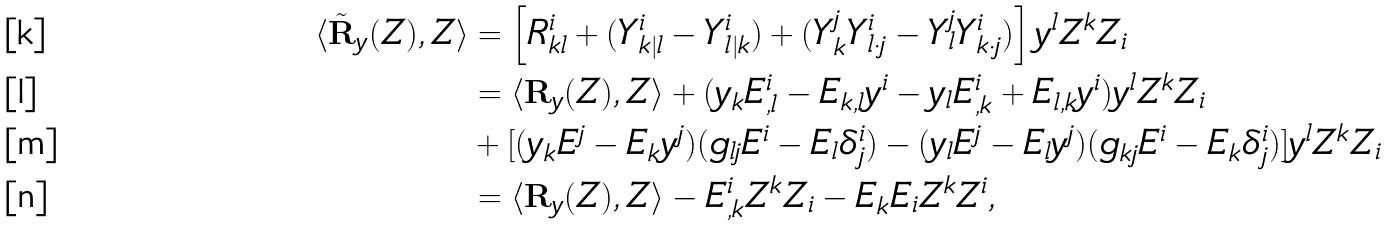Convert formula to latex. <formula><loc_0><loc_0><loc_500><loc_500>\langle \tilde { \mathbf R } _ { y } ( Z ) , Z \rangle & = \left [ R ^ { i } _ { k l } + ( Y ^ { i } _ { k | l } - Y ^ { i } _ { l | k } ) + ( Y ^ { j } _ { k } Y ^ { i } _ { l \cdot j } - Y ^ { j } _ { l } Y ^ { i } _ { k \cdot j } ) \right ] y ^ { l } Z ^ { k } Z _ { i } \\ & = \langle \mathbf R _ { y } ( Z ) , Z \rangle + ( y _ { k } E ^ { i } _ { , l } - E _ { k , l } y ^ { i } - y _ { l } E ^ { i } _ { , k } + E _ { l , k } y ^ { i } ) y ^ { l } Z ^ { k } Z _ { i } \\ & + [ ( y _ { k } E ^ { j } - E _ { k } y ^ { j } ) ( g _ { l j } E ^ { i } - E _ { l } \delta ^ { i } _ { j } ) - ( y _ { l } E ^ { j } - E _ { l } y ^ { j } ) ( g _ { k j } E ^ { i } - E _ { k } \delta ^ { i } _ { j } ) ] y ^ { l } Z ^ { k } Z _ { i } \\ & = \langle \mathbf R _ { y } ( Z ) , Z \rangle - E ^ { i } _ { , k } Z ^ { k } Z _ { i } - E _ { k } E _ { i } Z ^ { k } Z ^ { i } ,</formula> 